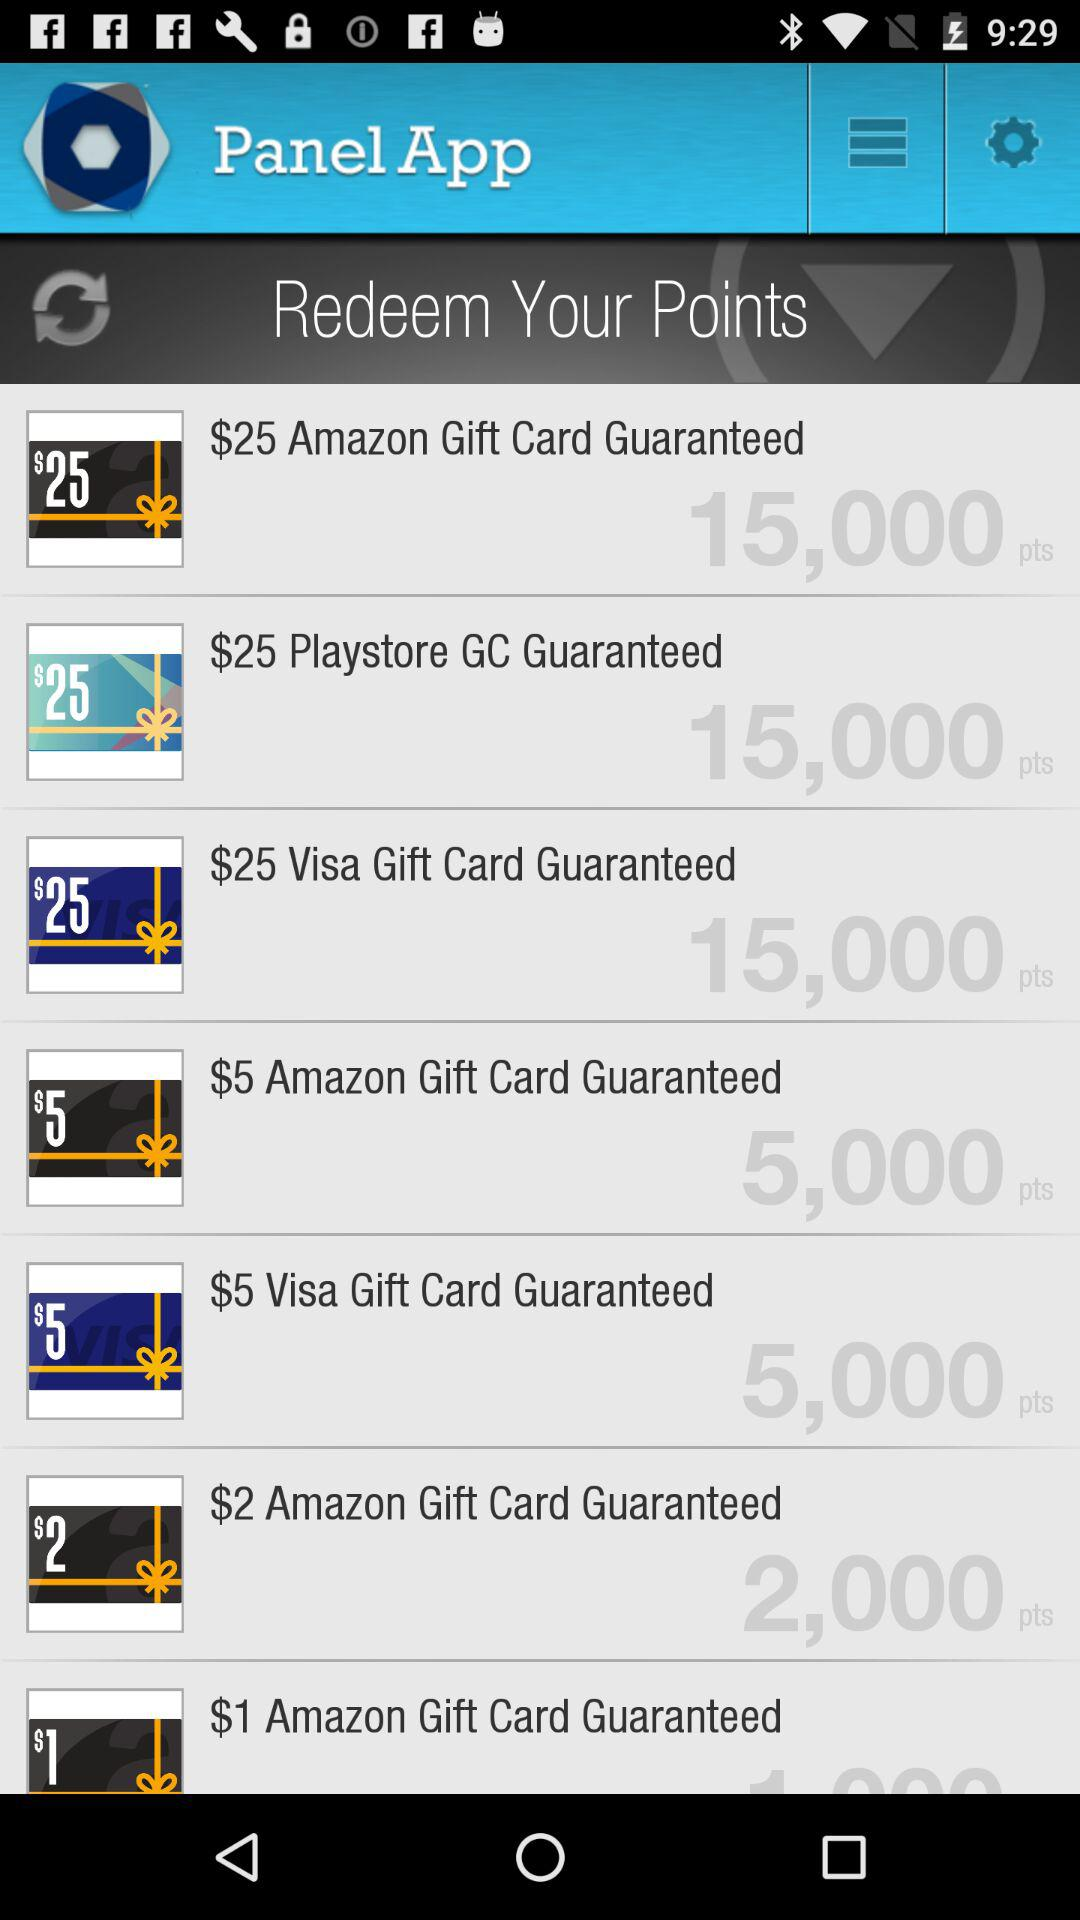How many points are required to redeem the $25 Amazon Gift Card?
Answer the question using a single word or phrase. 15,000 